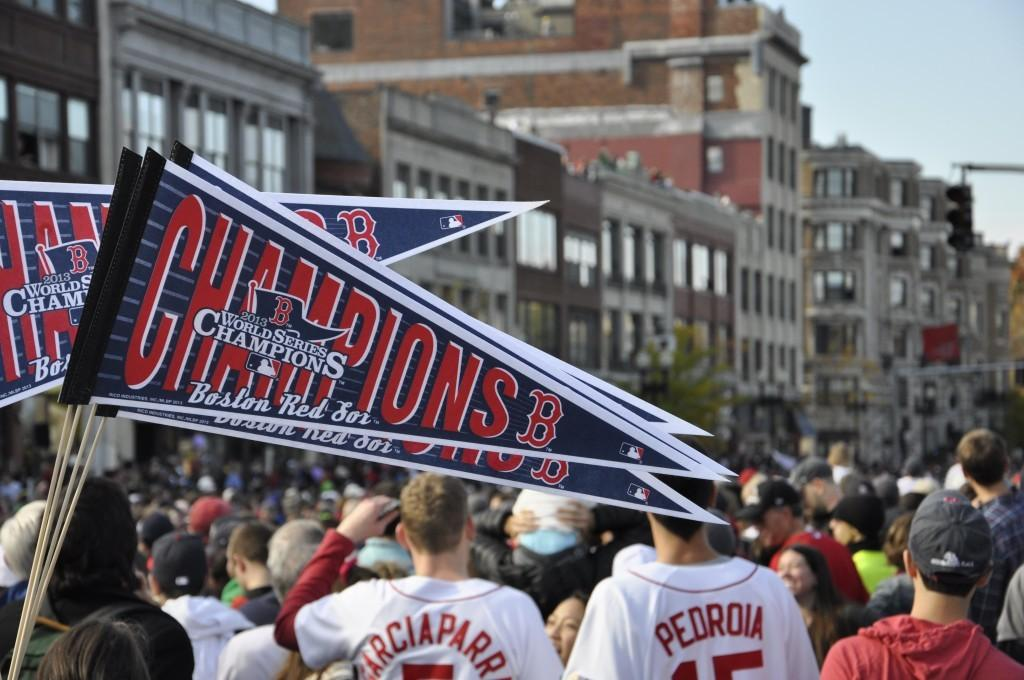<image>
Summarize the visual content of the image. The game patrons are tailgating for the Boston Red Sox game that will start soon. 